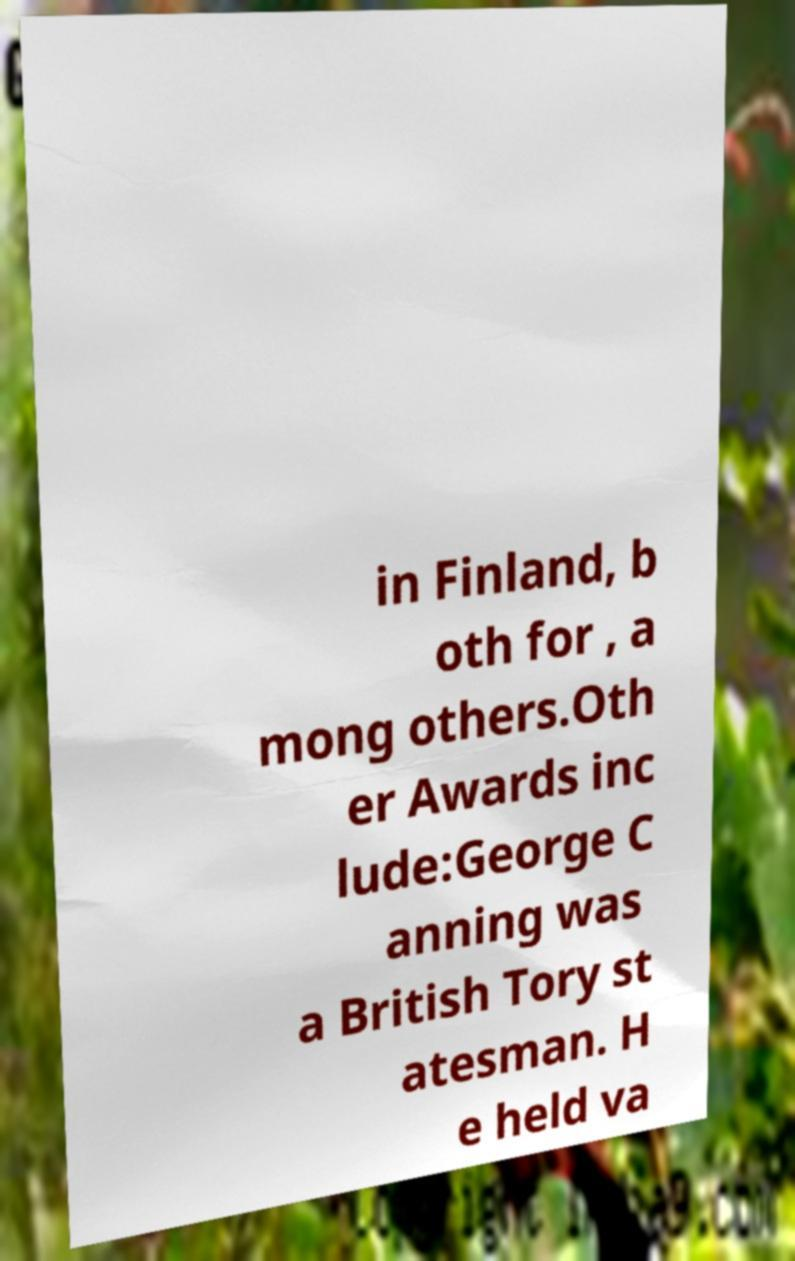I need the written content from this picture converted into text. Can you do that? in Finland, b oth for , a mong others.Oth er Awards inc lude:George C anning was a British Tory st atesman. H e held va 